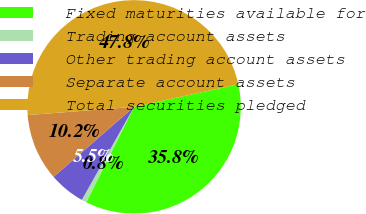<chart> <loc_0><loc_0><loc_500><loc_500><pie_chart><fcel>Fixed maturities available for<fcel>Trading account assets<fcel>Other trading account assets<fcel>Separate account assets<fcel>Total securities pledged<nl><fcel>35.78%<fcel>0.75%<fcel>5.46%<fcel>10.17%<fcel>47.84%<nl></chart> 